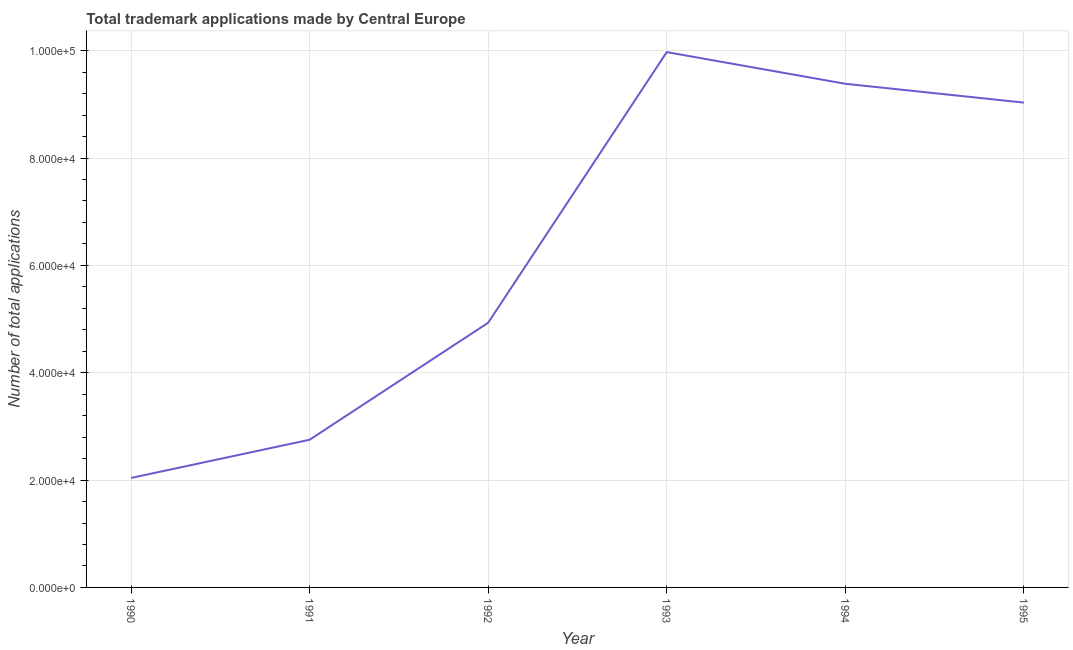What is the number of trademark applications in 1995?
Offer a very short reply. 9.03e+04. Across all years, what is the maximum number of trademark applications?
Provide a short and direct response. 9.97e+04. Across all years, what is the minimum number of trademark applications?
Your answer should be compact. 2.04e+04. What is the sum of the number of trademark applications?
Provide a succinct answer. 3.81e+05. What is the difference between the number of trademark applications in 1990 and 1993?
Your answer should be compact. -7.93e+04. What is the average number of trademark applications per year?
Provide a short and direct response. 6.35e+04. What is the median number of trademark applications?
Your response must be concise. 6.98e+04. In how many years, is the number of trademark applications greater than 80000 ?
Offer a very short reply. 3. Do a majority of the years between 1994 and 1992 (inclusive) have number of trademark applications greater than 72000 ?
Your response must be concise. No. What is the ratio of the number of trademark applications in 1992 to that in 1993?
Make the answer very short. 0.49. Is the number of trademark applications in 1992 less than that in 1993?
Provide a short and direct response. Yes. What is the difference between the highest and the second highest number of trademark applications?
Ensure brevity in your answer.  5899. What is the difference between the highest and the lowest number of trademark applications?
Your answer should be very brief. 7.93e+04. Does the graph contain any zero values?
Provide a succinct answer. No. Does the graph contain grids?
Make the answer very short. Yes. What is the title of the graph?
Your response must be concise. Total trademark applications made by Central Europe. What is the label or title of the Y-axis?
Provide a succinct answer. Number of total applications. What is the Number of total applications of 1990?
Ensure brevity in your answer.  2.04e+04. What is the Number of total applications of 1991?
Your answer should be compact. 2.75e+04. What is the Number of total applications of 1992?
Ensure brevity in your answer.  4.93e+04. What is the Number of total applications in 1993?
Your answer should be very brief. 9.97e+04. What is the Number of total applications in 1994?
Provide a short and direct response. 9.38e+04. What is the Number of total applications of 1995?
Offer a terse response. 9.03e+04. What is the difference between the Number of total applications in 1990 and 1991?
Your answer should be compact. -7119. What is the difference between the Number of total applications in 1990 and 1992?
Provide a succinct answer. -2.89e+04. What is the difference between the Number of total applications in 1990 and 1993?
Your answer should be very brief. -7.93e+04. What is the difference between the Number of total applications in 1990 and 1994?
Give a very brief answer. -7.34e+04. What is the difference between the Number of total applications in 1990 and 1995?
Provide a succinct answer. -6.99e+04. What is the difference between the Number of total applications in 1991 and 1992?
Provide a short and direct response. -2.18e+04. What is the difference between the Number of total applications in 1991 and 1993?
Provide a short and direct response. -7.22e+04. What is the difference between the Number of total applications in 1991 and 1994?
Ensure brevity in your answer.  -6.63e+04. What is the difference between the Number of total applications in 1991 and 1995?
Your response must be concise. -6.28e+04. What is the difference between the Number of total applications in 1992 and 1993?
Your response must be concise. -5.04e+04. What is the difference between the Number of total applications in 1992 and 1994?
Keep it short and to the point. -4.45e+04. What is the difference between the Number of total applications in 1992 and 1995?
Offer a terse response. -4.10e+04. What is the difference between the Number of total applications in 1993 and 1994?
Your answer should be very brief. 5899. What is the difference between the Number of total applications in 1993 and 1995?
Provide a succinct answer. 9407. What is the difference between the Number of total applications in 1994 and 1995?
Give a very brief answer. 3508. What is the ratio of the Number of total applications in 1990 to that in 1991?
Keep it short and to the point. 0.74. What is the ratio of the Number of total applications in 1990 to that in 1992?
Your answer should be very brief. 0.41. What is the ratio of the Number of total applications in 1990 to that in 1993?
Keep it short and to the point. 0.2. What is the ratio of the Number of total applications in 1990 to that in 1994?
Offer a very short reply. 0.22. What is the ratio of the Number of total applications in 1990 to that in 1995?
Your response must be concise. 0.23. What is the ratio of the Number of total applications in 1991 to that in 1992?
Offer a very short reply. 0.56. What is the ratio of the Number of total applications in 1991 to that in 1993?
Your answer should be compact. 0.28. What is the ratio of the Number of total applications in 1991 to that in 1994?
Your answer should be very brief. 0.29. What is the ratio of the Number of total applications in 1991 to that in 1995?
Offer a terse response. 0.3. What is the ratio of the Number of total applications in 1992 to that in 1993?
Your answer should be very brief. 0.49. What is the ratio of the Number of total applications in 1992 to that in 1994?
Provide a succinct answer. 0.53. What is the ratio of the Number of total applications in 1992 to that in 1995?
Your response must be concise. 0.55. What is the ratio of the Number of total applications in 1993 to that in 1994?
Make the answer very short. 1.06. What is the ratio of the Number of total applications in 1993 to that in 1995?
Provide a short and direct response. 1.1. What is the ratio of the Number of total applications in 1994 to that in 1995?
Provide a short and direct response. 1.04. 